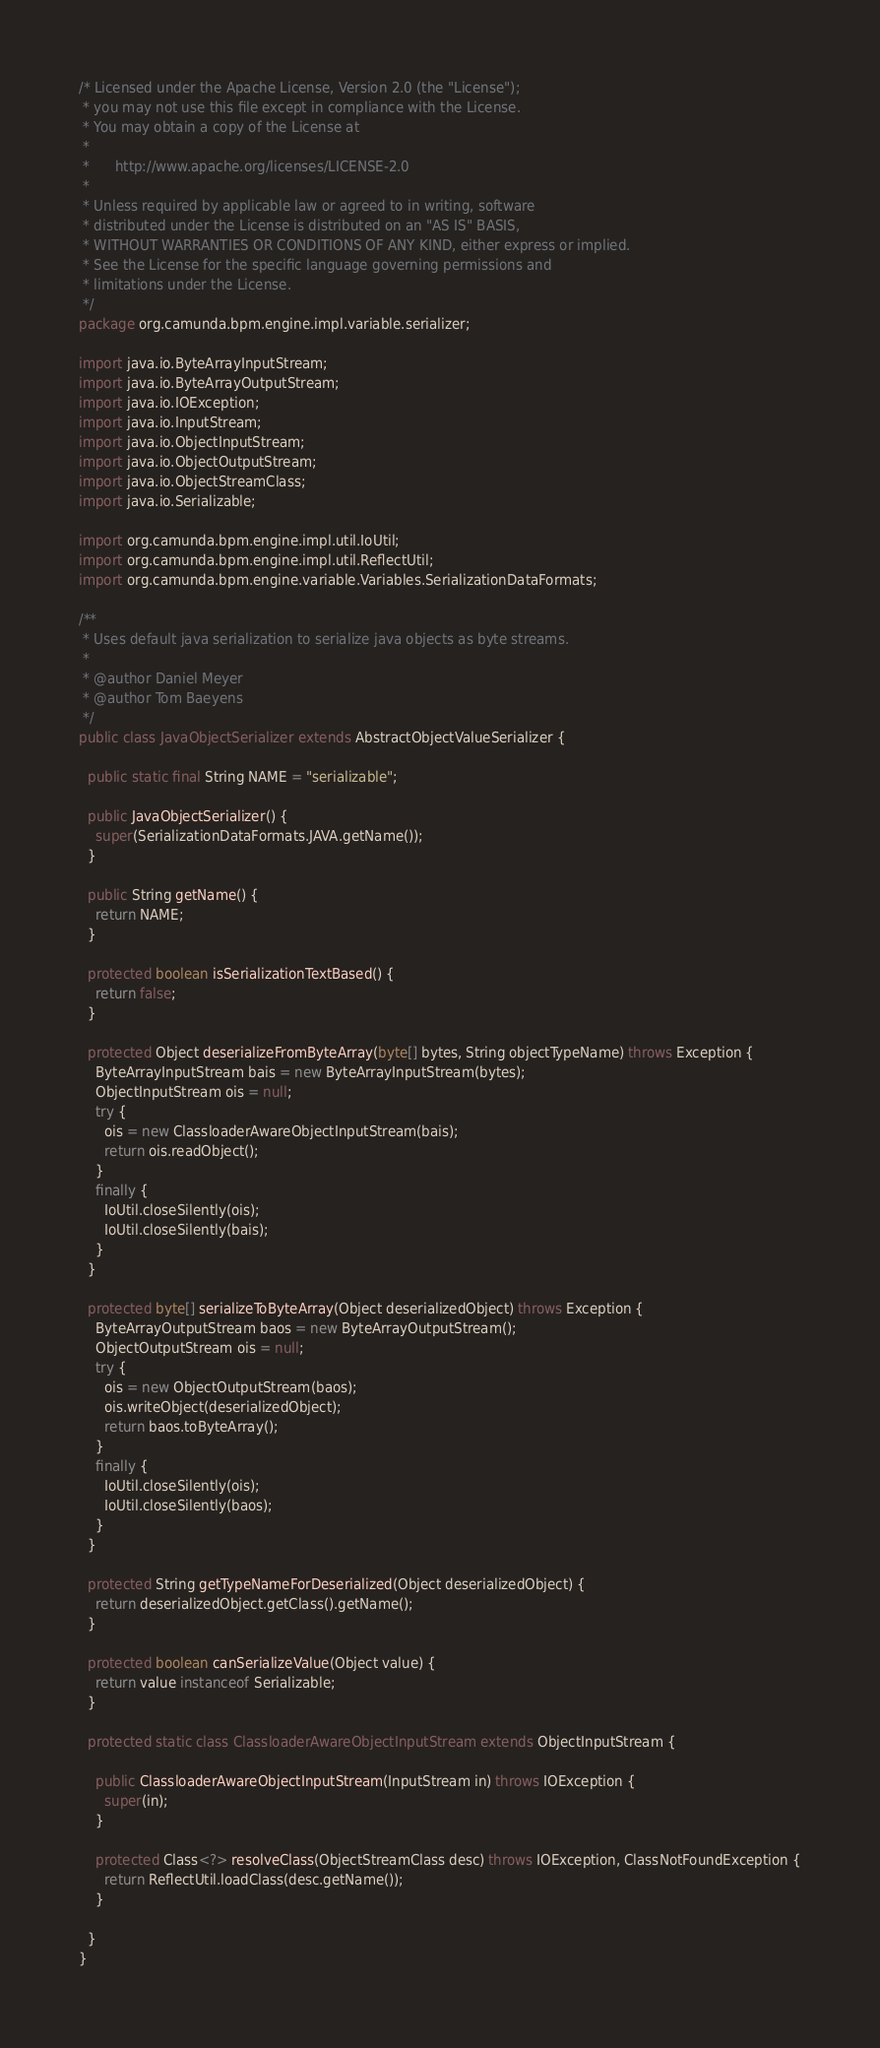<code> <loc_0><loc_0><loc_500><loc_500><_Java_>/* Licensed under the Apache License, Version 2.0 (the "License");
 * you may not use this file except in compliance with the License.
 * You may obtain a copy of the License at
 *
 *      http://www.apache.org/licenses/LICENSE-2.0
 *
 * Unless required by applicable law or agreed to in writing, software
 * distributed under the License is distributed on an "AS IS" BASIS,
 * WITHOUT WARRANTIES OR CONDITIONS OF ANY KIND, either express or implied.
 * See the License for the specific language governing permissions and
 * limitations under the License.
 */
package org.camunda.bpm.engine.impl.variable.serializer;

import java.io.ByteArrayInputStream;
import java.io.ByteArrayOutputStream;
import java.io.IOException;
import java.io.InputStream;
import java.io.ObjectInputStream;
import java.io.ObjectOutputStream;
import java.io.ObjectStreamClass;
import java.io.Serializable;

import org.camunda.bpm.engine.impl.util.IoUtil;
import org.camunda.bpm.engine.impl.util.ReflectUtil;
import org.camunda.bpm.engine.variable.Variables.SerializationDataFormats;

/**
 * Uses default java serialization to serialize java objects as byte streams.
 *
 * @author Daniel Meyer
 * @author Tom Baeyens
 */
public class JavaObjectSerializer extends AbstractObjectValueSerializer {

  public static final String NAME = "serializable";

  public JavaObjectSerializer() {
    super(SerializationDataFormats.JAVA.getName());
  }

  public String getName() {
    return NAME;
  }

  protected boolean isSerializationTextBased() {
    return false;
  }

  protected Object deserializeFromByteArray(byte[] bytes, String objectTypeName) throws Exception {
    ByteArrayInputStream bais = new ByteArrayInputStream(bytes);
    ObjectInputStream ois = null;
    try {
      ois = new ClassloaderAwareObjectInputStream(bais);
      return ois.readObject();
    }
    finally {
      IoUtil.closeSilently(ois);
      IoUtil.closeSilently(bais);
    }
  }

  protected byte[] serializeToByteArray(Object deserializedObject) throws Exception {
    ByteArrayOutputStream baos = new ByteArrayOutputStream();
    ObjectOutputStream ois = null;
    try {
      ois = new ObjectOutputStream(baos);
      ois.writeObject(deserializedObject);
      return baos.toByteArray();
    }
    finally {
      IoUtil.closeSilently(ois);
      IoUtil.closeSilently(baos);
    }
  }

  protected String getTypeNameForDeserialized(Object deserializedObject) {
    return deserializedObject.getClass().getName();
  }

  protected boolean canSerializeValue(Object value) {
    return value instanceof Serializable;
  }

  protected static class ClassloaderAwareObjectInputStream extends ObjectInputStream {

    public ClassloaderAwareObjectInputStream(InputStream in) throws IOException {
      super(in);
    }

    protected Class<?> resolveClass(ObjectStreamClass desc) throws IOException, ClassNotFoundException {
      return ReflectUtil.loadClass(desc.getName());
    }

  }
}
</code> 